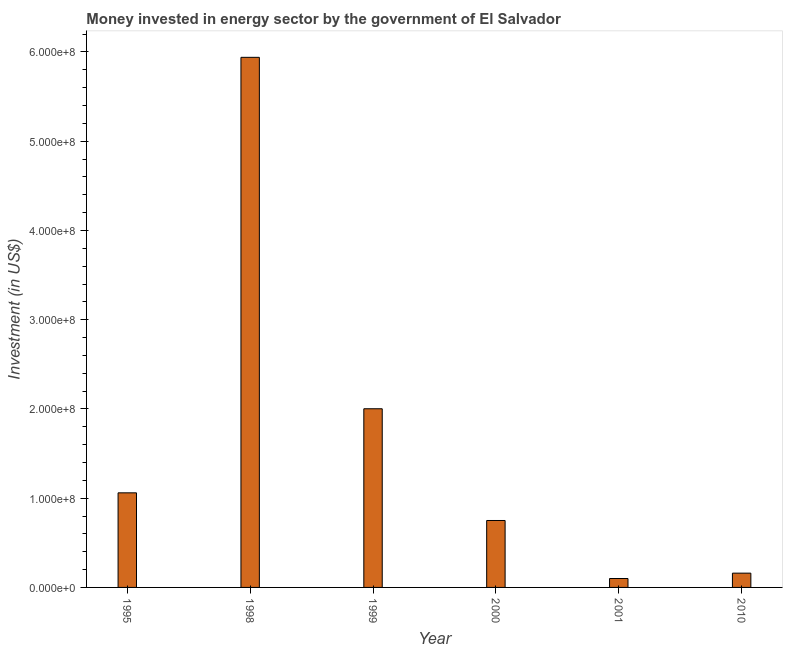What is the title of the graph?
Keep it short and to the point. Money invested in energy sector by the government of El Salvador. What is the label or title of the Y-axis?
Offer a very short reply. Investment (in US$). What is the investment in energy in 1998?
Your response must be concise. 5.94e+08. Across all years, what is the maximum investment in energy?
Your response must be concise. 5.94e+08. In which year was the investment in energy minimum?
Your answer should be compact. 2001. What is the sum of the investment in energy?
Make the answer very short. 1.00e+09. What is the difference between the investment in energy in 1999 and 2001?
Offer a terse response. 1.90e+08. What is the average investment in energy per year?
Your answer should be compact. 1.67e+08. What is the median investment in energy?
Offer a terse response. 9.05e+07. What is the ratio of the investment in energy in 2001 to that in 2010?
Provide a succinct answer. 0.62. Is the investment in energy in 1999 less than that in 2001?
Offer a very short reply. No. Is the difference between the investment in energy in 1995 and 2010 greater than the difference between any two years?
Ensure brevity in your answer.  No. What is the difference between the highest and the second highest investment in energy?
Give a very brief answer. 3.94e+08. Is the sum of the investment in energy in 1998 and 2000 greater than the maximum investment in energy across all years?
Your answer should be compact. Yes. What is the difference between the highest and the lowest investment in energy?
Offer a very short reply. 5.84e+08. How many bars are there?
Keep it short and to the point. 6. Are all the bars in the graph horizontal?
Your answer should be compact. No. What is the Investment (in US$) of 1995?
Ensure brevity in your answer.  1.06e+08. What is the Investment (in US$) of 1998?
Provide a succinct answer. 5.94e+08. What is the Investment (in US$) in 1999?
Offer a very short reply. 2.00e+08. What is the Investment (in US$) in 2000?
Your answer should be compact. 7.50e+07. What is the Investment (in US$) of 2010?
Make the answer very short. 1.60e+07. What is the difference between the Investment (in US$) in 1995 and 1998?
Provide a succinct answer. -4.88e+08. What is the difference between the Investment (in US$) in 1995 and 1999?
Offer a very short reply. -9.42e+07. What is the difference between the Investment (in US$) in 1995 and 2000?
Provide a succinct answer. 3.10e+07. What is the difference between the Investment (in US$) in 1995 and 2001?
Make the answer very short. 9.60e+07. What is the difference between the Investment (in US$) in 1995 and 2010?
Offer a terse response. 9.00e+07. What is the difference between the Investment (in US$) in 1998 and 1999?
Provide a short and direct response. 3.94e+08. What is the difference between the Investment (in US$) in 1998 and 2000?
Ensure brevity in your answer.  5.19e+08. What is the difference between the Investment (in US$) in 1998 and 2001?
Ensure brevity in your answer.  5.84e+08. What is the difference between the Investment (in US$) in 1998 and 2010?
Your response must be concise. 5.78e+08. What is the difference between the Investment (in US$) in 1999 and 2000?
Ensure brevity in your answer.  1.25e+08. What is the difference between the Investment (in US$) in 1999 and 2001?
Make the answer very short. 1.90e+08. What is the difference between the Investment (in US$) in 1999 and 2010?
Your answer should be very brief. 1.84e+08. What is the difference between the Investment (in US$) in 2000 and 2001?
Make the answer very short. 6.50e+07. What is the difference between the Investment (in US$) in 2000 and 2010?
Offer a very short reply. 5.90e+07. What is the difference between the Investment (in US$) in 2001 and 2010?
Keep it short and to the point. -6.00e+06. What is the ratio of the Investment (in US$) in 1995 to that in 1998?
Keep it short and to the point. 0.18. What is the ratio of the Investment (in US$) in 1995 to that in 1999?
Provide a short and direct response. 0.53. What is the ratio of the Investment (in US$) in 1995 to that in 2000?
Provide a succinct answer. 1.41. What is the ratio of the Investment (in US$) in 1995 to that in 2010?
Keep it short and to the point. 6.62. What is the ratio of the Investment (in US$) in 1998 to that in 1999?
Your response must be concise. 2.97. What is the ratio of the Investment (in US$) in 1998 to that in 2000?
Your answer should be compact. 7.92. What is the ratio of the Investment (in US$) in 1998 to that in 2001?
Your answer should be very brief. 59.4. What is the ratio of the Investment (in US$) in 1998 to that in 2010?
Provide a succinct answer. 37.12. What is the ratio of the Investment (in US$) in 1999 to that in 2000?
Your response must be concise. 2.67. What is the ratio of the Investment (in US$) in 1999 to that in 2001?
Provide a succinct answer. 20.02. What is the ratio of the Investment (in US$) in 1999 to that in 2010?
Provide a short and direct response. 12.51. What is the ratio of the Investment (in US$) in 2000 to that in 2010?
Your response must be concise. 4.69. What is the ratio of the Investment (in US$) in 2001 to that in 2010?
Keep it short and to the point. 0.62. 